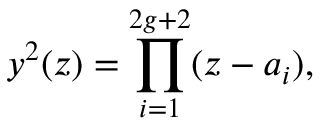<formula> <loc_0><loc_0><loc_500><loc_500>y ^ { 2 } ( z ) = \prod _ { i = 1 } ^ { 2 g + 2 } ( z - a _ { i } ) ,</formula> 